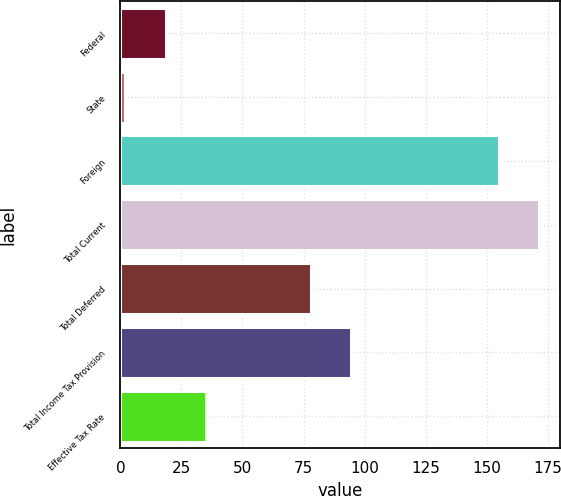Convert chart to OTSL. <chart><loc_0><loc_0><loc_500><loc_500><bar_chart><fcel>Federal<fcel>State<fcel>Foreign<fcel>Total Current<fcel>Total Deferred<fcel>Total Income Tax Provision<fcel>Effective Tax Rate<nl><fcel>18.6<fcel>2<fcel>155<fcel>171.6<fcel>78<fcel>94.6<fcel>35.2<nl></chart> 